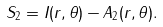Convert formula to latex. <formula><loc_0><loc_0><loc_500><loc_500>S _ { 2 } = I ( r , \theta ) - A _ { 2 } ( r , \theta ) .</formula> 